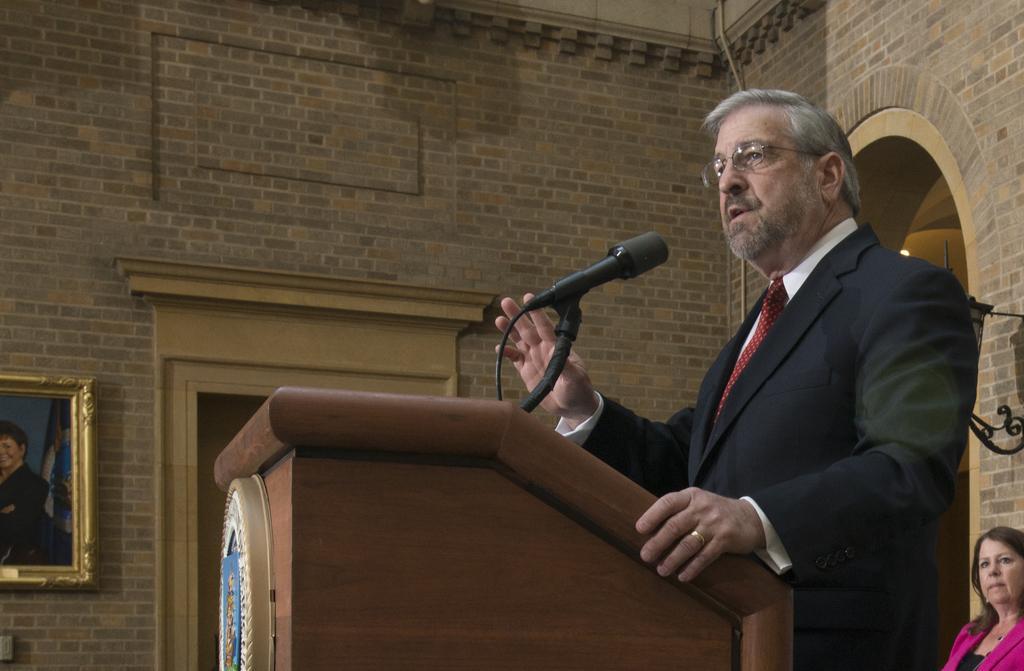Could you give a brief overview of what you see in this image? In this image on the right there is a man, he wears a suit, shirt, tie, in front of him there is a podium and mic, behind him there is a woman, she wears a suit, her hair is short. In the background there is a photo frame, door, light and wall. 